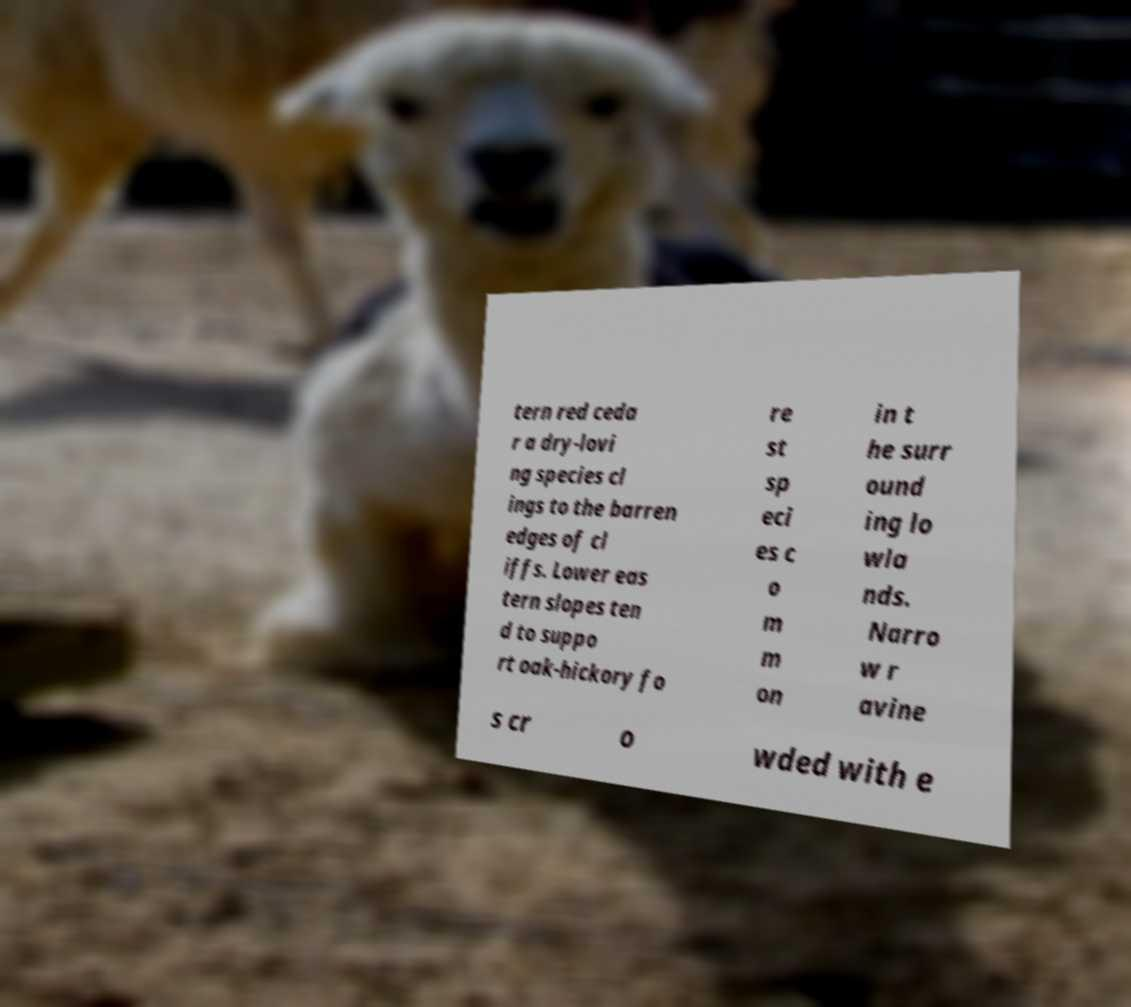Can you read and provide the text displayed in the image?This photo seems to have some interesting text. Can you extract and type it out for me? tern red ceda r a dry-lovi ng species cl ings to the barren edges of cl iffs. Lower eas tern slopes ten d to suppo rt oak-hickory fo re st sp eci es c o m m on in t he surr ound ing lo wla nds. Narro w r avine s cr o wded with e 